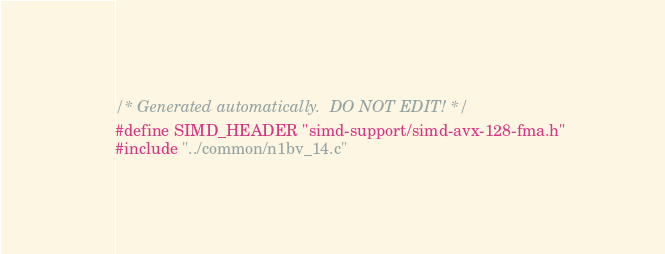Convert code to text. <code><loc_0><loc_0><loc_500><loc_500><_C_>/* Generated automatically.  DO NOT EDIT! */
#define SIMD_HEADER "simd-support/simd-avx-128-fma.h"
#include "../common/n1bv_14.c"
</code> 